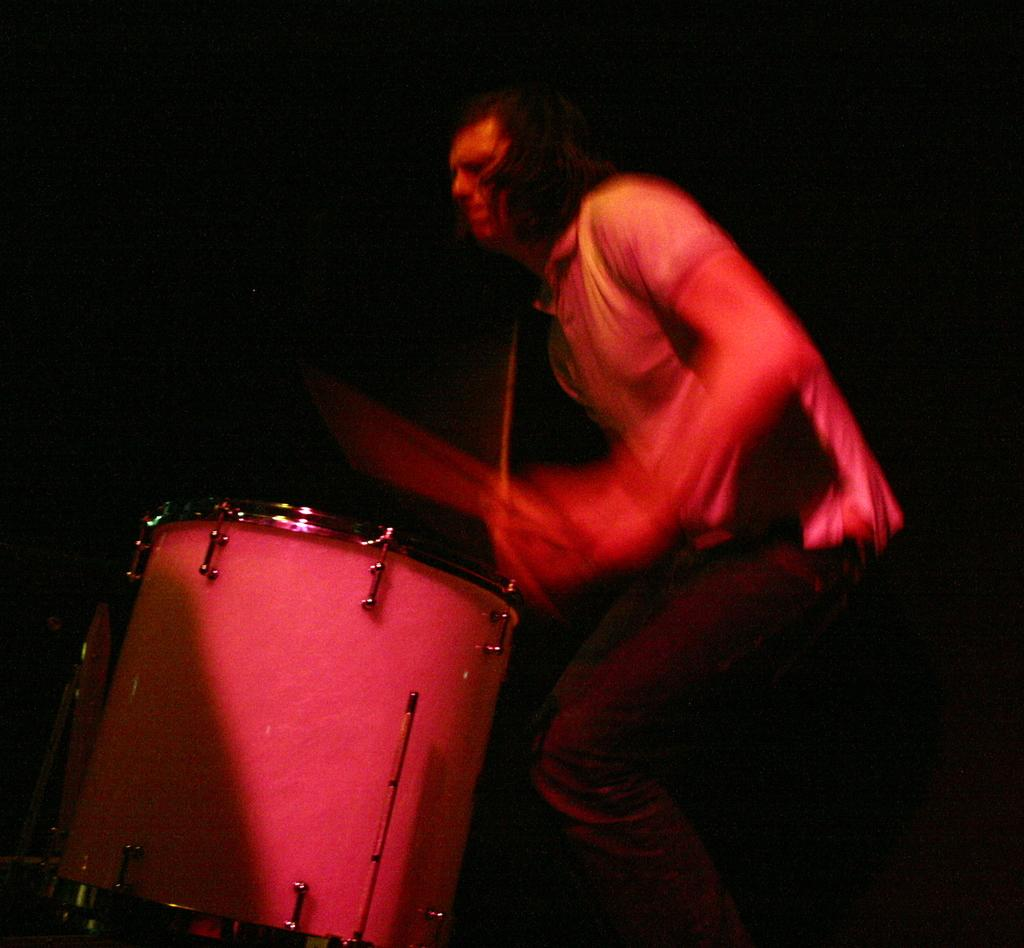What is the main subject of the image? The main subject of the image is a person. What is the person in the image doing? The person is playing a musical instrument. Can you describe any additional features about the person in the image? Yes, there is lighting on the person. Can you tell me how many giraffes are visible in the image? There are no giraffes present in the image. What type of jeans is the person wearing in the image? The provided facts do not mention the type of jeans the person is wearing, if any. 